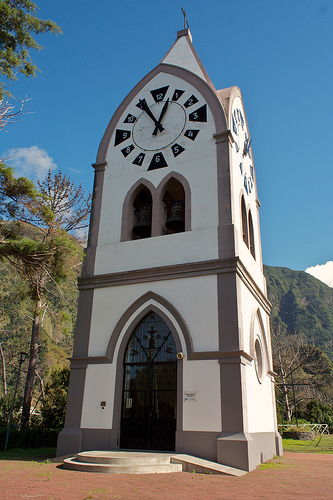What is under the clock in the top? Below the clock, there is a bell housed within the tower. 